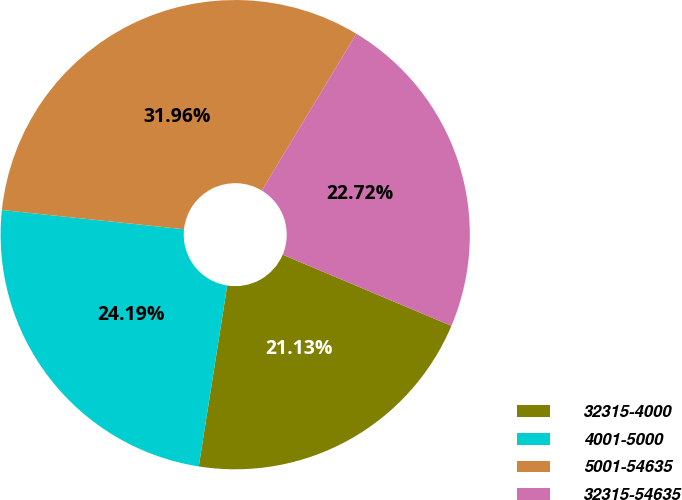<chart> <loc_0><loc_0><loc_500><loc_500><pie_chart><fcel>32315-4000<fcel>4001-5000<fcel>5001-54635<fcel>32315-54635<nl><fcel>21.13%<fcel>24.19%<fcel>31.96%<fcel>22.72%<nl></chart> 